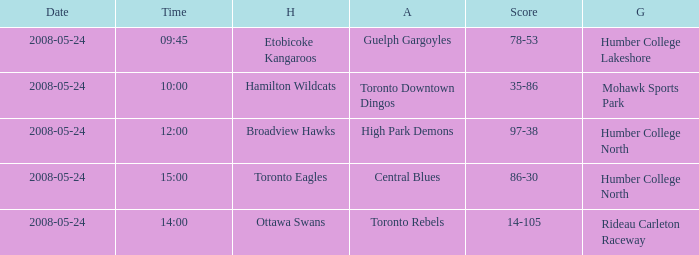Who was the home team of the game at the time of 14:00? Ottawa Swans. 